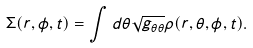<formula> <loc_0><loc_0><loc_500><loc_500>\Sigma ( r , \phi , t ) = \int d \theta \sqrt { g _ { \theta \theta } } \rho ( r , \theta , \phi , t ) .</formula> 